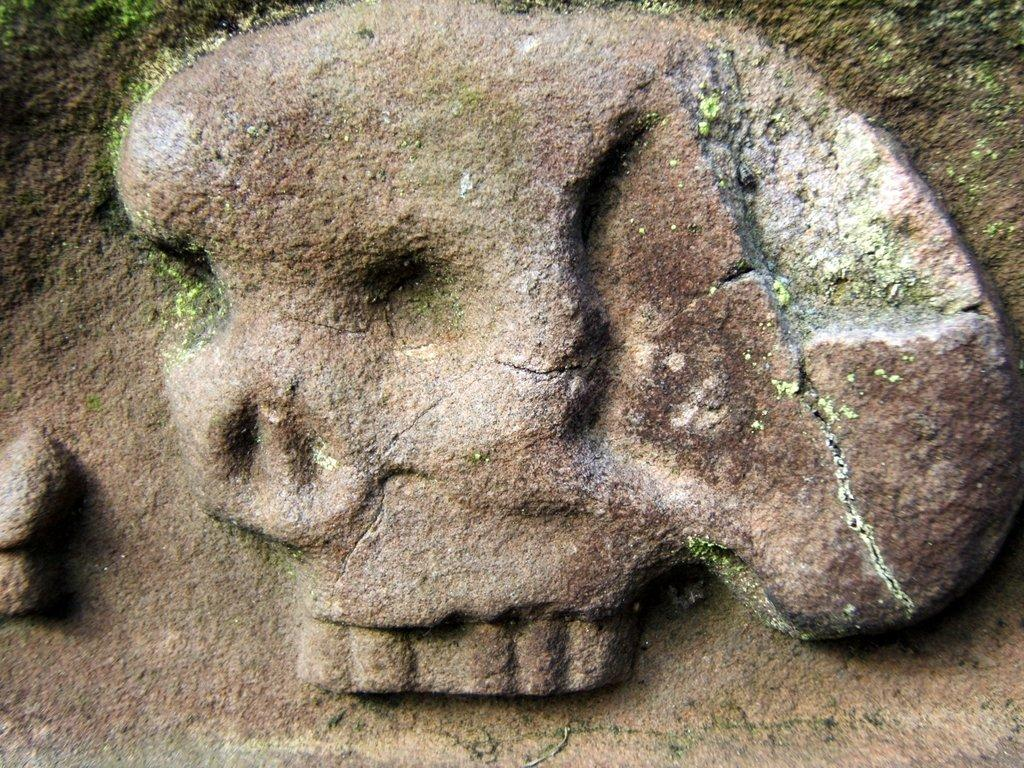What type of sculpture is depicted in the image? There is a rock cut sculpture in the image. Where is the toothbrush placed in the image? There is no toothbrush present in the image. What type of plastic object can be seen in the image? There is no plastic object present in the image. 